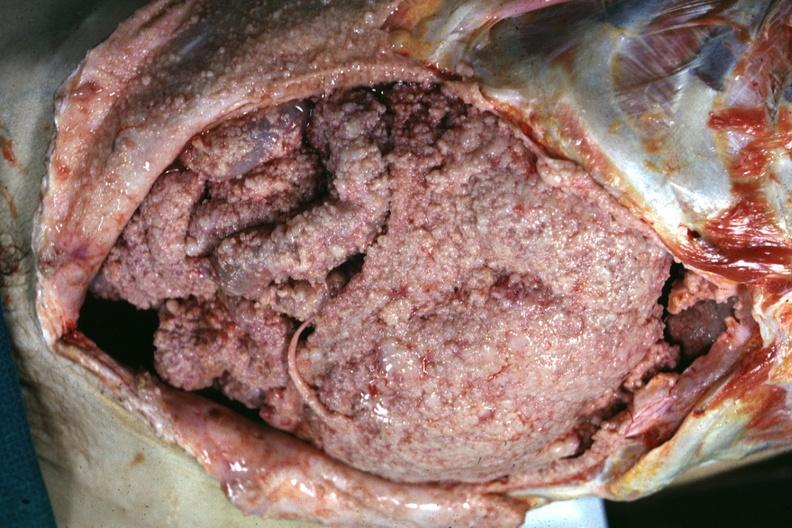s carcinomatosis present?
Answer the question using a single word or phrase. No 